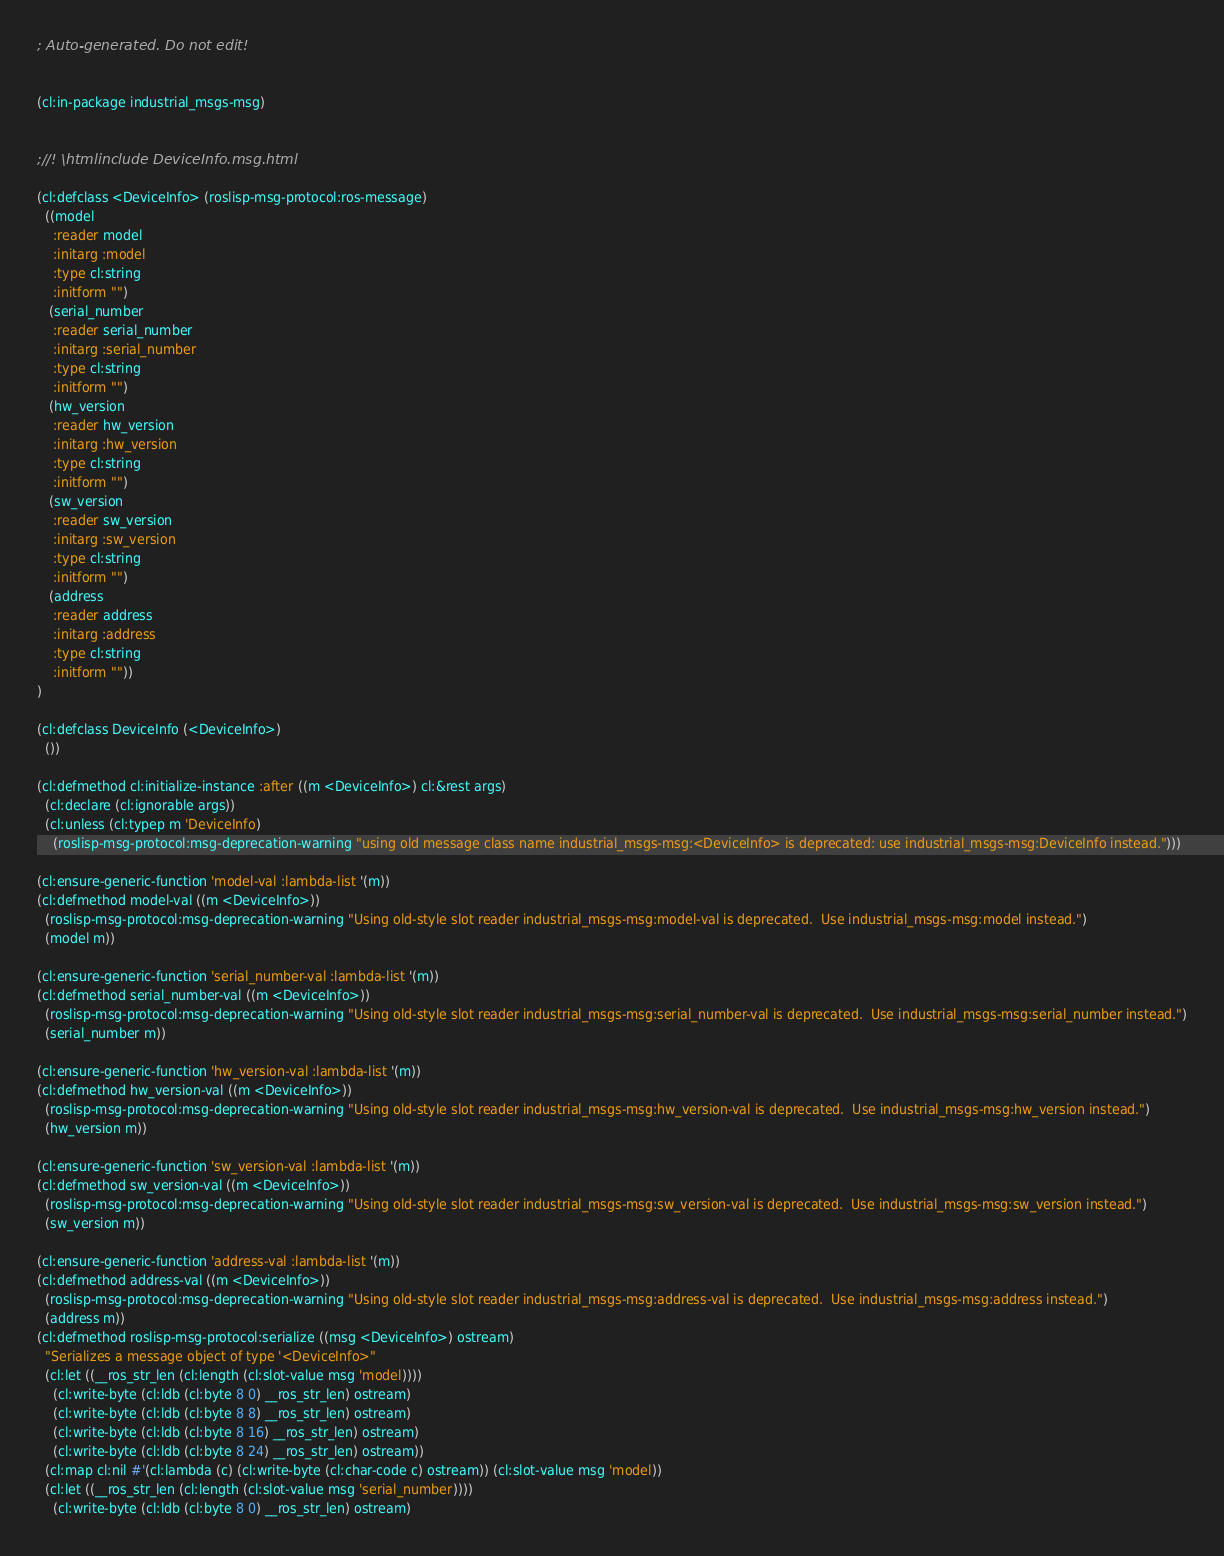<code> <loc_0><loc_0><loc_500><loc_500><_Lisp_>; Auto-generated. Do not edit!


(cl:in-package industrial_msgs-msg)


;//! \htmlinclude DeviceInfo.msg.html

(cl:defclass <DeviceInfo> (roslisp-msg-protocol:ros-message)
  ((model
    :reader model
    :initarg :model
    :type cl:string
    :initform "")
   (serial_number
    :reader serial_number
    :initarg :serial_number
    :type cl:string
    :initform "")
   (hw_version
    :reader hw_version
    :initarg :hw_version
    :type cl:string
    :initform "")
   (sw_version
    :reader sw_version
    :initarg :sw_version
    :type cl:string
    :initform "")
   (address
    :reader address
    :initarg :address
    :type cl:string
    :initform ""))
)

(cl:defclass DeviceInfo (<DeviceInfo>)
  ())

(cl:defmethod cl:initialize-instance :after ((m <DeviceInfo>) cl:&rest args)
  (cl:declare (cl:ignorable args))
  (cl:unless (cl:typep m 'DeviceInfo)
    (roslisp-msg-protocol:msg-deprecation-warning "using old message class name industrial_msgs-msg:<DeviceInfo> is deprecated: use industrial_msgs-msg:DeviceInfo instead.")))

(cl:ensure-generic-function 'model-val :lambda-list '(m))
(cl:defmethod model-val ((m <DeviceInfo>))
  (roslisp-msg-protocol:msg-deprecation-warning "Using old-style slot reader industrial_msgs-msg:model-val is deprecated.  Use industrial_msgs-msg:model instead.")
  (model m))

(cl:ensure-generic-function 'serial_number-val :lambda-list '(m))
(cl:defmethod serial_number-val ((m <DeviceInfo>))
  (roslisp-msg-protocol:msg-deprecation-warning "Using old-style slot reader industrial_msgs-msg:serial_number-val is deprecated.  Use industrial_msgs-msg:serial_number instead.")
  (serial_number m))

(cl:ensure-generic-function 'hw_version-val :lambda-list '(m))
(cl:defmethod hw_version-val ((m <DeviceInfo>))
  (roslisp-msg-protocol:msg-deprecation-warning "Using old-style slot reader industrial_msgs-msg:hw_version-val is deprecated.  Use industrial_msgs-msg:hw_version instead.")
  (hw_version m))

(cl:ensure-generic-function 'sw_version-val :lambda-list '(m))
(cl:defmethod sw_version-val ((m <DeviceInfo>))
  (roslisp-msg-protocol:msg-deprecation-warning "Using old-style slot reader industrial_msgs-msg:sw_version-val is deprecated.  Use industrial_msgs-msg:sw_version instead.")
  (sw_version m))

(cl:ensure-generic-function 'address-val :lambda-list '(m))
(cl:defmethod address-val ((m <DeviceInfo>))
  (roslisp-msg-protocol:msg-deprecation-warning "Using old-style slot reader industrial_msgs-msg:address-val is deprecated.  Use industrial_msgs-msg:address instead.")
  (address m))
(cl:defmethod roslisp-msg-protocol:serialize ((msg <DeviceInfo>) ostream)
  "Serializes a message object of type '<DeviceInfo>"
  (cl:let ((__ros_str_len (cl:length (cl:slot-value msg 'model))))
    (cl:write-byte (cl:ldb (cl:byte 8 0) __ros_str_len) ostream)
    (cl:write-byte (cl:ldb (cl:byte 8 8) __ros_str_len) ostream)
    (cl:write-byte (cl:ldb (cl:byte 8 16) __ros_str_len) ostream)
    (cl:write-byte (cl:ldb (cl:byte 8 24) __ros_str_len) ostream))
  (cl:map cl:nil #'(cl:lambda (c) (cl:write-byte (cl:char-code c) ostream)) (cl:slot-value msg 'model))
  (cl:let ((__ros_str_len (cl:length (cl:slot-value msg 'serial_number))))
    (cl:write-byte (cl:ldb (cl:byte 8 0) __ros_str_len) ostream)</code> 